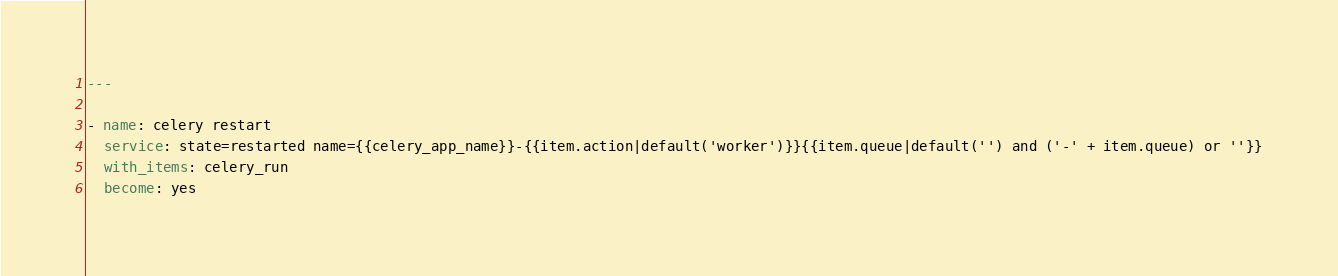Convert code to text. <code><loc_0><loc_0><loc_500><loc_500><_YAML_>---

- name: celery restart
  service: state=restarted name={{celery_app_name}}-{{item.action|default('worker')}}{{item.queue|default('') and ('-' + item.queue) or ''}}
  with_items: celery_run
  become: yes
</code> 